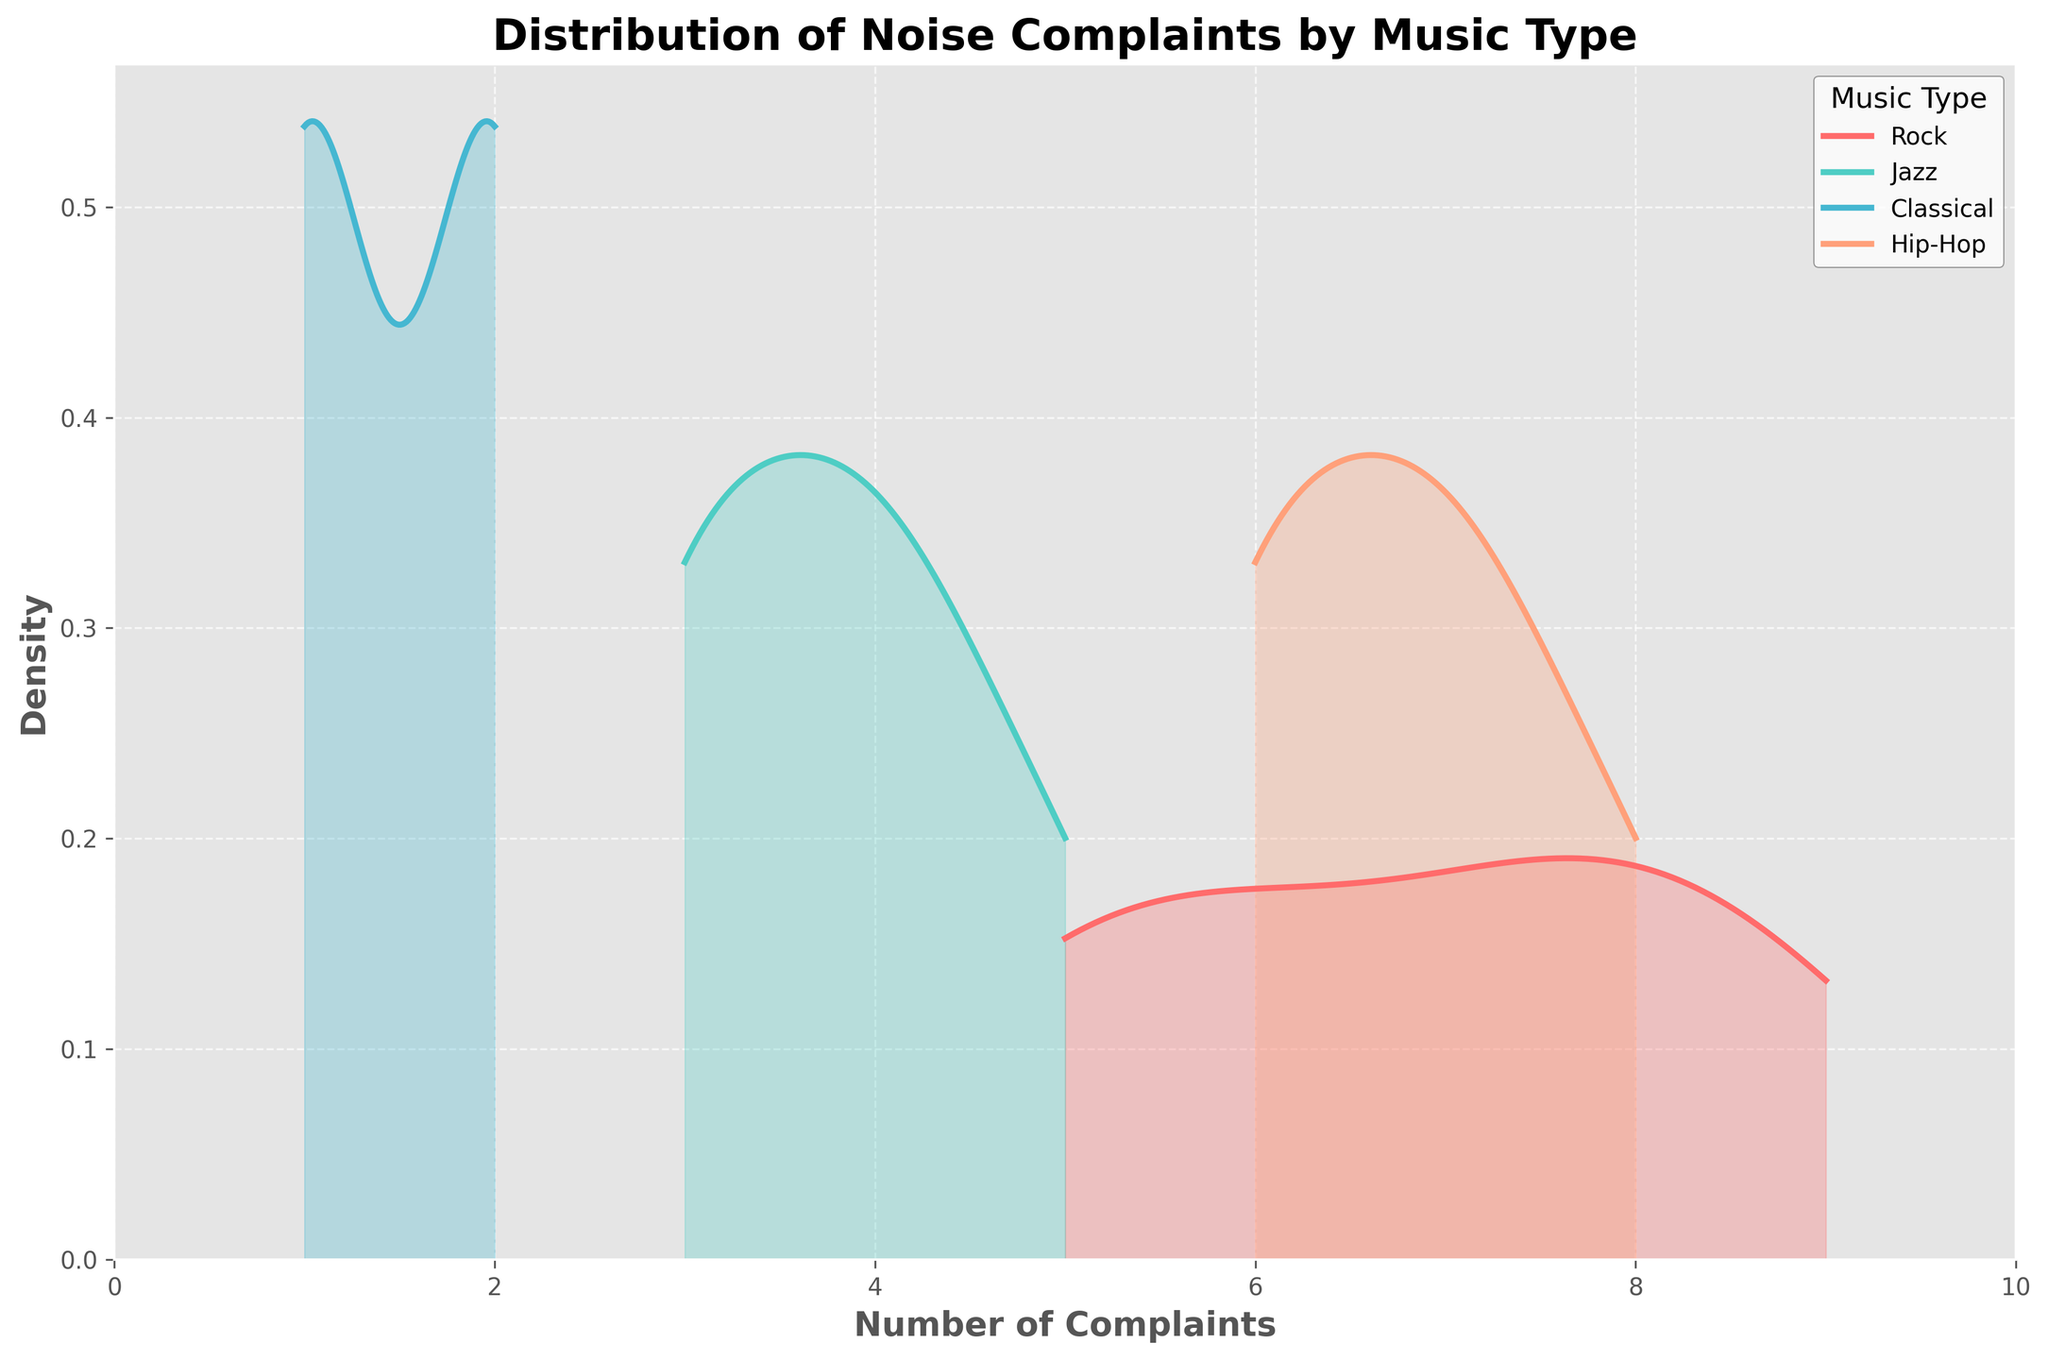What's the title of the figure? The title of the figure is displayed at the top center and reads "Distribution of Noise Complaints by Music Type".
Answer: Distribution of Noise Complaints by Music Type Which axis shows the number of complaints? The x-axis shows the number of complaints.
Answer: x-axis What color represents Jazz music? The color representing Jazz music can be identified by looking at the legend; it corresponds to a turquoise color.
Answer: turquoise What is the maximum number of complaints registered for Rock music? By observing the x-axis range for Rock music's density plot, the highest value is 9.
Answer: 9 How does the density of complaints for Hip-Hop music compare to Rock music? To compare the densities, observe the height and spread of the curves for Hip-Hop and Rock music. Rock music has a broader spread with higher peaks, whereas Hip-Hop has somewhat lower peaks and a narrower spread.
Answer: Rock music has higher peaks and a broader spread Does Classical music have a wider or narrower distribution of complaints compared to Jazz? By comparing the width of the density plots, Classical music's complaints distribution is narrower, whereas Jazz covers a broader range.
Answer: narrower What's the general trend of density curves for Hip-Hop and Classical music? Hip-Hop's density curve usually peaks around higher complaint numbers, while Classical music's curve peaks around lower complaint numbers.
Answer: Hip-Hop peaks higher, Classical peaks lower Between which two complaint numbers does Rock music show the highest density? Observing the peak of the Rock music density curve, it is highest between around 6 and 8 complaints.
Answer: 6 and 8 Which music type shows the lowest density of noise complaints around 1-2 complaints? Observing the density curves around 1-2 complaints, Hip-Hop shows the lowest density compared to other music types.
Answer: Hip-Hop What are the colors representing Classical and Hip-Hop music? Classical music is represented by light pink, and Hip-Hop is represented by light orange as per the legend on the plot.
Answer: light pink for Classical and light orange for Hip-Hop 